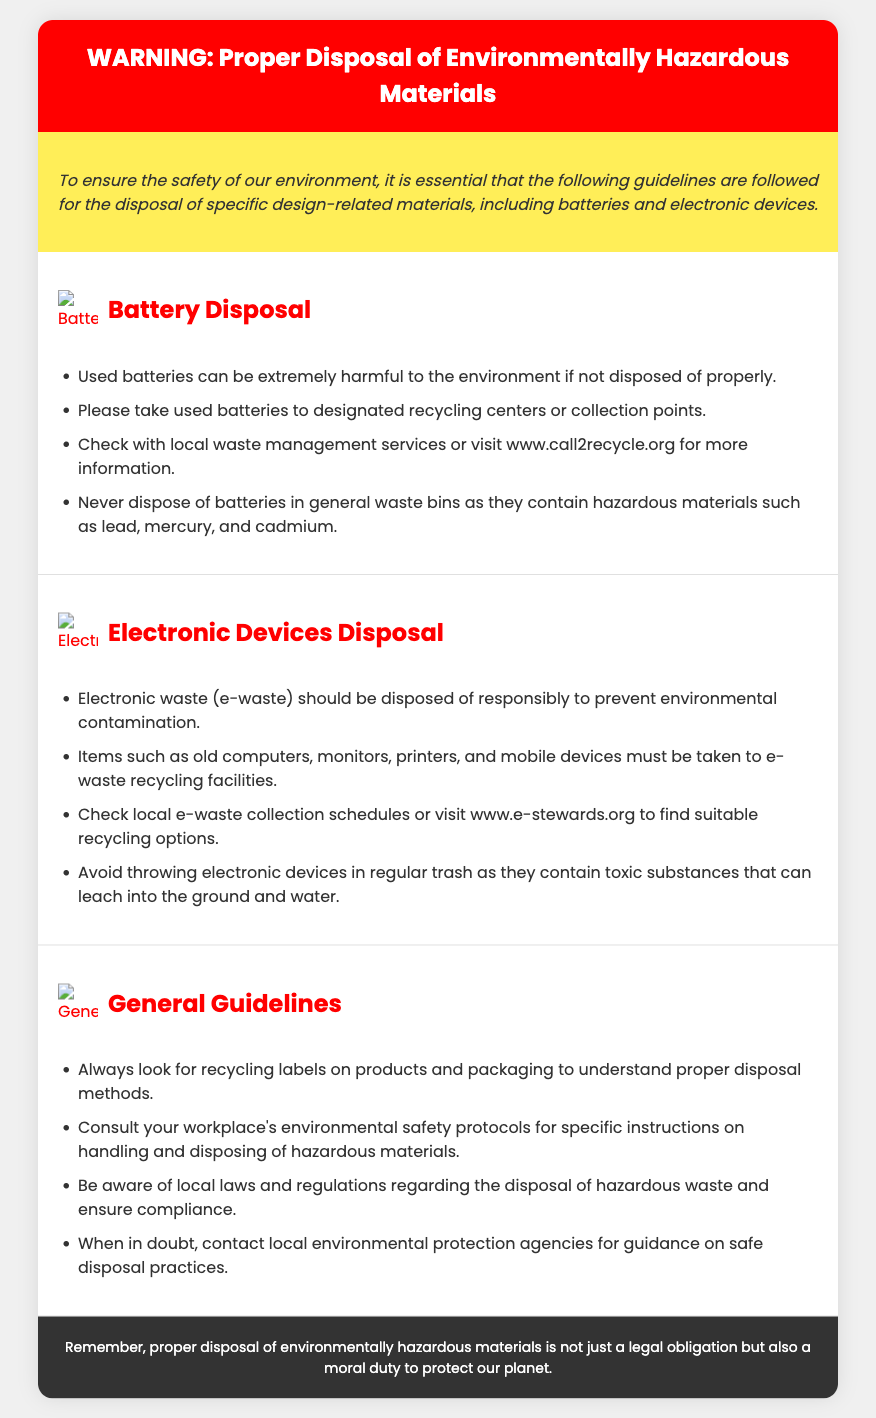What is the main warning topic? The primary focus of the warning label is the proper disposal of hazardous materials.
Answer: Proper Disposal of Environmentally Hazardous Materials Where should used batteries be taken? Used batteries must be taken to designated recycling centers or collection points.
Answer: Designated recycling centers What substances can be found in batteries? The document mentions lead, mercury, and cadmium as hazardous materials found in batteries.
Answer: Lead, mercury, cadmium What is the website for battery recycling information? The document provides a specific website for more information on battery recycling.
Answer: www.call2recycle.org What items are included in electronic waste? Examples provided for electronic waste include old computers, monitors, printers, and mobile devices.
Answer: Old computers, monitors, printers, and mobile devices What should be avoided in relation to electronic devices? It is advised to avoid throwing electronic devices in regular trash due to their hazardous substances.
Answer: Throwing electronic devices in regular trash What is suggested for local hazardous waste disposal laws? The document advises being aware of local laws and regulations regarding hazardous waste disposal.
Answer: Local laws and regulations Which recycling symbol is associated with electronic devices? The document mentions an image that represents the electronic devices recycling symbol.
Answer: Recycling symbol for electronic devices What moral duty is mentioned regarding disposal? The text emphasizes a moral duty along with legal obligations in the context of waste disposal.
Answer: Moral duty to protect our planet 